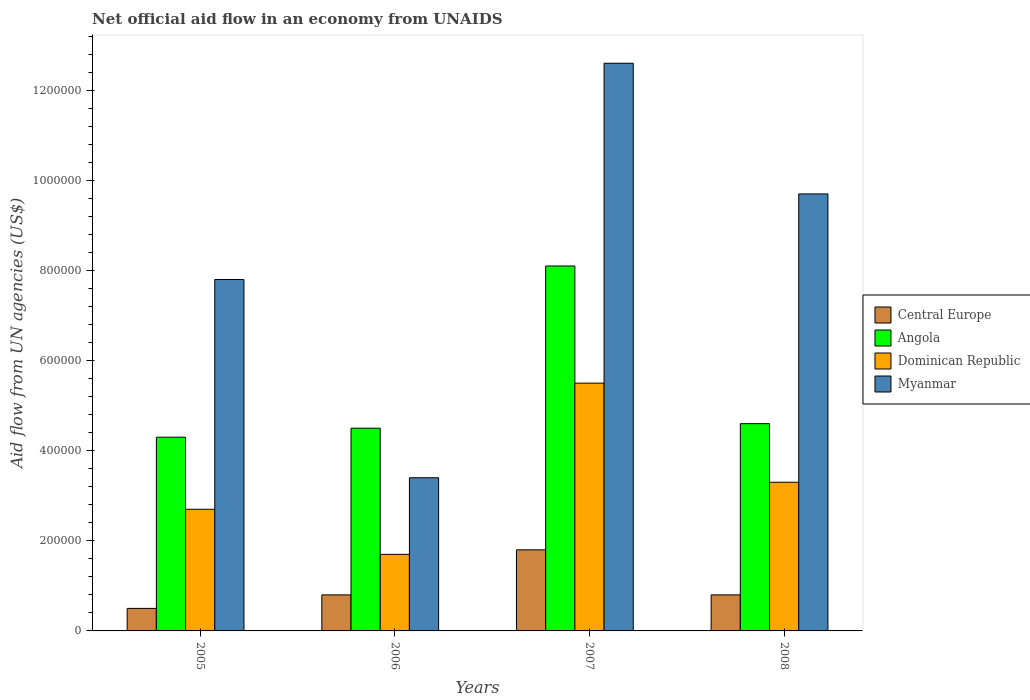How many different coloured bars are there?
Make the answer very short. 4. How many groups of bars are there?
Give a very brief answer. 4. Are the number of bars on each tick of the X-axis equal?
Your answer should be compact. Yes. How many bars are there on the 2nd tick from the left?
Keep it short and to the point. 4. How many bars are there on the 3rd tick from the right?
Make the answer very short. 4. What is the net official aid flow in Dominican Republic in 2006?
Your response must be concise. 1.70e+05. Across all years, what is the maximum net official aid flow in Myanmar?
Give a very brief answer. 1.26e+06. Across all years, what is the minimum net official aid flow in Myanmar?
Your response must be concise. 3.40e+05. In which year was the net official aid flow in Angola maximum?
Offer a terse response. 2007. What is the total net official aid flow in Dominican Republic in the graph?
Provide a succinct answer. 1.32e+06. What is the difference between the net official aid flow in Myanmar in 2005 and that in 2006?
Give a very brief answer. 4.40e+05. What is the average net official aid flow in Angola per year?
Provide a succinct answer. 5.38e+05. In the year 2007, what is the difference between the net official aid flow in Myanmar and net official aid flow in Angola?
Make the answer very short. 4.50e+05. In how many years, is the net official aid flow in Myanmar greater than 720000 US$?
Your answer should be very brief. 3. Is the net official aid flow in Angola in 2005 less than that in 2008?
Keep it short and to the point. Yes. What is the difference between the highest and the second highest net official aid flow in Myanmar?
Give a very brief answer. 2.90e+05. What is the difference between the highest and the lowest net official aid flow in Myanmar?
Offer a very short reply. 9.20e+05. In how many years, is the net official aid flow in Angola greater than the average net official aid flow in Angola taken over all years?
Your answer should be compact. 1. Is it the case that in every year, the sum of the net official aid flow in Myanmar and net official aid flow in Angola is greater than the sum of net official aid flow in Central Europe and net official aid flow in Dominican Republic?
Offer a terse response. No. What does the 2nd bar from the left in 2006 represents?
Your answer should be compact. Angola. What does the 2nd bar from the right in 2008 represents?
Your response must be concise. Dominican Republic. Is it the case that in every year, the sum of the net official aid flow in Dominican Republic and net official aid flow in Myanmar is greater than the net official aid flow in Central Europe?
Your answer should be very brief. Yes. Are all the bars in the graph horizontal?
Keep it short and to the point. No. How many years are there in the graph?
Give a very brief answer. 4. Are the values on the major ticks of Y-axis written in scientific E-notation?
Your answer should be compact. No. Does the graph contain grids?
Give a very brief answer. No. How many legend labels are there?
Provide a short and direct response. 4. How are the legend labels stacked?
Ensure brevity in your answer.  Vertical. What is the title of the graph?
Offer a terse response. Net official aid flow in an economy from UNAIDS. Does "Gabon" appear as one of the legend labels in the graph?
Provide a succinct answer. No. What is the label or title of the Y-axis?
Your response must be concise. Aid flow from UN agencies (US$). What is the Aid flow from UN agencies (US$) of Dominican Republic in 2005?
Offer a very short reply. 2.70e+05. What is the Aid flow from UN agencies (US$) in Myanmar in 2005?
Give a very brief answer. 7.80e+05. What is the Aid flow from UN agencies (US$) in Angola in 2006?
Provide a short and direct response. 4.50e+05. What is the Aid flow from UN agencies (US$) in Dominican Republic in 2006?
Provide a short and direct response. 1.70e+05. What is the Aid flow from UN agencies (US$) in Myanmar in 2006?
Your answer should be compact. 3.40e+05. What is the Aid flow from UN agencies (US$) of Central Europe in 2007?
Provide a short and direct response. 1.80e+05. What is the Aid flow from UN agencies (US$) in Angola in 2007?
Offer a very short reply. 8.10e+05. What is the Aid flow from UN agencies (US$) of Myanmar in 2007?
Keep it short and to the point. 1.26e+06. What is the Aid flow from UN agencies (US$) in Dominican Republic in 2008?
Offer a terse response. 3.30e+05. What is the Aid flow from UN agencies (US$) in Myanmar in 2008?
Provide a short and direct response. 9.70e+05. Across all years, what is the maximum Aid flow from UN agencies (US$) in Central Europe?
Provide a succinct answer. 1.80e+05. Across all years, what is the maximum Aid flow from UN agencies (US$) in Angola?
Keep it short and to the point. 8.10e+05. Across all years, what is the maximum Aid flow from UN agencies (US$) in Myanmar?
Ensure brevity in your answer.  1.26e+06. Across all years, what is the minimum Aid flow from UN agencies (US$) in Central Europe?
Ensure brevity in your answer.  5.00e+04. Across all years, what is the minimum Aid flow from UN agencies (US$) of Angola?
Give a very brief answer. 4.30e+05. Across all years, what is the minimum Aid flow from UN agencies (US$) in Dominican Republic?
Your answer should be very brief. 1.70e+05. Across all years, what is the minimum Aid flow from UN agencies (US$) in Myanmar?
Offer a terse response. 3.40e+05. What is the total Aid flow from UN agencies (US$) in Angola in the graph?
Keep it short and to the point. 2.15e+06. What is the total Aid flow from UN agencies (US$) of Dominican Republic in the graph?
Give a very brief answer. 1.32e+06. What is the total Aid flow from UN agencies (US$) in Myanmar in the graph?
Provide a succinct answer. 3.35e+06. What is the difference between the Aid flow from UN agencies (US$) in Angola in 2005 and that in 2006?
Your answer should be very brief. -2.00e+04. What is the difference between the Aid flow from UN agencies (US$) in Myanmar in 2005 and that in 2006?
Keep it short and to the point. 4.40e+05. What is the difference between the Aid flow from UN agencies (US$) in Angola in 2005 and that in 2007?
Your response must be concise. -3.80e+05. What is the difference between the Aid flow from UN agencies (US$) of Dominican Republic in 2005 and that in 2007?
Your answer should be compact. -2.80e+05. What is the difference between the Aid flow from UN agencies (US$) of Myanmar in 2005 and that in 2007?
Ensure brevity in your answer.  -4.80e+05. What is the difference between the Aid flow from UN agencies (US$) of Central Europe in 2005 and that in 2008?
Provide a succinct answer. -3.00e+04. What is the difference between the Aid flow from UN agencies (US$) of Dominican Republic in 2005 and that in 2008?
Make the answer very short. -6.00e+04. What is the difference between the Aid flow from UN agencies (US$) in Myanmar in 2005 and that in 2008?
Offer a terse response. -1.90e+05. What is the difference between the Aid flow from UN agencies (US$) in Central Europe in 2006 and that in 2007?
Keep it short and to the point. -1.00e+05. What is the difference between the Aid flow from UN agencies (US$) of Angola in 2006 and that in 2007?
Keep it short and to the point. -3.60e+05. What is the difference between the Aid flow from UN agencies (US$) of Dominican Republic in 2006 and that in 2007?
Your answer should be compact. -3.80e+05. What is the difference between the Aid flow from UN agencies (US$) in Myanmar in 2006 and that in 2007?
Give a very brief answer. -9.20e+05. What is the difference between the Aid flow from UN agencies (US$) of Central Europe in 2006 and that in 2008?
Your response must be concise. 0. What is the difference between the Aid flow from UN agencies (US$) of Myanmar in 2006 and that in 2008?
Your response must be concise. -6.30e+05. What is the difference between the Aid flow from UN agencies (US$) of Central Europe in 2007 and that in 2008?
Provide a short and direct response. 1.00e+05. What is the difference between the Aid flow from UN agencies (US$) in Angola in 2007 and that in 2008?
Give a very brief answer. 3.50e+05. What is the difference between the Aid flow from UN agencies (US$) of Central Europe in 2005 and the Aid flow from UN agencies (US$) of Angola in 2006?
Your response must be concise. -4.00e+05. What is the difference between the Aid flow from UN agencies (US$) in Central Europe in 2005 and the Aid flow from UN agencies (US$) in Dominican Republic in 2006?
Offer a terse response. -1.20e+05. What is the difference between the Aid flow from UN agencies (US$) in Angola in 2005 and the Aid flow from UN agencies (US$) in Dominican Republic in 2006?
Your response must be concise. 2.60e+05. What is the difference between the Aid flow from UN agencies (US$) of Angola in 2005 and the Aid flow from UN agencies (US$) of Myanmar in 2006?
Your response must be concise. 9.00e+04. What is the difference between the Aid flow from UN agencies (US$) in Central Europe in 2005 and the Aid flow from UN agencies (US$) in Angola in 2007?
Give a very brief answer. -7.60e+05. What is the difference between the Aid flow from UN agencies (US$) of Central Europe in 2005 and the Aid flow from UN agencies (US$) of Dominican Republic in 2007?
Make the answer very short. -5.00e+05. What is the difference between the Aid flow from UN agencies (US$) of Central Europe in 2005 and the Aid flow from UN agencies (US$) of Myanmar in 2007?
Your answer should be very brief. -1.21e+06. What is the difference between the Aid flow from UN agencies (US$) in Angola in 2005 and the Aid flow from UN agencies (US$) in Myanmar in 2007?
Keep it short and to the point. -8.30e+05. What is the difference between the Aid flow from UN agencies (US$) of Dominican Republic in 2005 and the Aid flow from UN agencies (US$) of Myanmar in 2007?
Provide a short and direct response. -9.90e+05. What is the difference between the Aid flow from UN agencies (US$) of Central Europe in 2005 and the Aid flow from UN agencies (US$) of Angola in 2008?
Provide a succinct answer. -4.10e+05. What is the difference between the Aid flow from UN agencies (US$) of Central Europe in 2005 and the Aid flow from UN agencies (US$) of Dominican Republic in 2008?
Your answer should be compact. -2.80e+05. What is the difference between the Aid flow from UN agencies (US$) in Central Europe in 2005 and the Aid flow from UN agencies (US$) in Myanmar in 2008?
Offer a very short reply. -9.20e+05. What is the difference between the Aid flow from UN agencies (US$) of Angola in 2005 and the Aid flow from UN agencies (US$) of Dominican Republic in 2008?
Offer a very short reply. 1.00e+05. What is the difference between the Aid flow from UN agencies (US$) of Angola in 2005 and the Aid flow from UN agencies (US$) of Myanmar in 2008?
Make the answer very short. -5.40e+05. What is the difference between the Aid flow from UN agencies (US$) in Dominican Republic in 2005 and the Aid flow from UN agencies (US$) in Myanmar in 2008?
Make the answer very short. -7.00e+05. What is the difference between the Aid flow from UN agencies (US$) of Central Europe in 2006 and the Aid flow from UN agencies (US$) of Angola in 2007?
Provide a short and direct response. -7.30e+05. What is the difference between the Aid flow from UN agencies (US$) of Central Europe in 2006 and the Aid flow from UN agencies (US$) of Dominican Republic in 2007?
Provide a short and direct response. -4.70e+05. What is the difference between the Aid flow from UN agencies (US$) of Central Europe in 2006 and the Aid flow from UN agencies (US$) of Myanmar in 2007?
Your response must be concise. -1.18e+06. What is the difference between the Aid flow from UN agencies (US$) in Angola in 2006 and the Aid flow from UN agencies (US$) in Dominican Republic in 2007?
Offer a very short reply. -1.00e+05. What is the difference between the Aid flow from UN agencies (US$) of Angola in 2006 and the Aid flow from UN agencies (US$) of Myanmar in 2007?
Keep it short and to the point. -8.10e+05. What is the difference between the Aid flow from UN agencies (US$) in Dominican Republic in 2006 and the Aid flow from UN agencies (US$) in Myanmar in 2007?
Ensure brevity in your answer.  -1.09e+06. What is the difference between the Aid flow from UN agencies (US$) in Central Europe in 2006 and the Aid flow from UN agencies (US$) in Angola in 2008?
Make the answer very short. -3.80e+05. What is the difference between the Aid flow from UN agencies (US$) of Central Europe in 2006 and the Aid flow from UN agencies (US$) of Myanmar in 2008?
Your answer should be compact. -8.90e+05. What is the difference between the Aid flow from UN agencies (US$) of Angola in 2006 and the Aid flow from UN agencies (US$) of Dominican Republic in 2008?
Provide a short and direct response. 1.20e+05. What is the difference between the Aid flow from UN agencies (US$) of Angola in 2006 and the Aid flow from UN agencies (US$) of Myanmar in 2008?
Your response must be concise. -5.20e+05. What is the difference between the Aid flow from UN agencies (US$) in Dominican Republic in 2006 and the Aid flow from UN agencies (US$) in Myanmar in 2008?
Your response must be concise. -8.00e+05. What is the difference between the Aid flow from UN agencies (US$) in Central Europe in 2007 and the Aid flow from UN agencies (US$) in Angola in 2008?
Provide a succinct answer. -2.80e+05. What is the difference between the Aid flow from UN agencies (US$) in Central Europe in 2007 and the Aid flow from UN agencies (US$) in Myanmar in 2008?
Offer a very short reply. -7.90e+05. What is the difference between the Aid flow from UN agencies (US$) in Angola in 2007 and the Aid flow from UN agencies (US$) in Dominican Republic in 2008?
Keep it short and to the point. 4.80e+05. What is the difference between the Aid flow from UN agencies (US$) of Angola in 2007 and the Aid flow from UN agencies (US$) of Myanmar in 2008?
Your answer should be compact. -1.60e+05. What is the difference between the Aid flow from UN agencies (US$) in Dominican Republic in 2007 and the Aid flow from UN agencies (US$) in Myanmar in 2008?
Give a very brief answer. -4.20e+05. What is the average Aid flow from UN agencies (US$) of Central Europe per year?
Your response must be concise. 9.75e+04. What is the average Aid flow from UN agencies (US$) of Angola per year?
Provide a short and direct response. 5.38e+05. What is the average Aid flow from UN agencies (US$) in Dominican Republic per year?
Provide a short and direct response. 3.30e+05. What is the average Aid flow from UN agencies (US$) in Myanmar per year?
Make the answer very short. 8.38e+05. In the year 2005, what is the difference between the Aid flow from UN agencies (US$) of Central Europe and Aid flow from UN agencies (US$) of Angola?
Your answer should be compact. -3.80e+05. In the year 2005, what is the difference between the Aid flow from UN agencies (US$) of Central Europe and Aid flow from UN agencies (US$) of Myanmar?
Keep it short and to the point. -7.30e+05. In the year 2005, what is the difference between the Aid flow from UN agencies (US$) in Angola and Aid flow from UN agencies (US$) in Dominican Republic?
Ensure brevity in your answer.  1.60e+05. In the year 2005, what is the difference between the Aid flow from UN agencies (US$) of Angola and Aid flow from UN agencies (US$) of Myanmar?
Keep it short and to the point. -3.50e+05. In the year 2005, what is the difference between the Aid flow from UN agencies (US$) of Dominican Republic and Aid flow from UN agencies (US$) of Myanmar?
Offer a terse response. -5.10e+05. In the year 2006, what is the difference between the Aid flow from UN agencies (US$) of Central Europe and Aid flow from UN agencies (US$) of Angola?
Offer a very short reply. -3.70e+05. In the year 2006, what is the difference between the Aid flow from UN agencies (US$) in Central Europe and Aid flow from UN agencies (US$) in Myanmar?
Keep it short and to the point. -2.60e+05. In the year 2006, what is the difference between the Aid flow from UN agencies (US$) of Angola and Aid flow from UN agencies (US$) of Myanmar?
Provide a succinct answer. 1.10e+05. In the year 2006, what is the difference between the Aid flow from UN agencies (US$) of Dominican Republic and Aid flow from UN agencies (US$) of Myanmar?
Offer a terse response. -1.70e+05. In the year 2007, what is the difference between the Aid flow from UN agencies (US$) in Central Europe and Aid flow from UN agencies (US$) in Angola?
Provide a succinct answer. -6.30e+05. In the year 2007, what is the difference between the Aid flow from UN agencies (US$) of Central Europe and Aid flow from UN agencies (US$) of Dominican Republic?
Make the answer very short. -3.70e+05. In the year 2007, what is the difference between the Aid flow from UN agencies (US$) of Central Europe and Aid flow from UN agencies (US$) of Myanmar?
Make the answer very short. -1.08e+06. In the year 2007, what is the difference between the Aid flow from UN agencies (US$) in Angola and Aid flow from UN agencies (US$) in Dominican Republic?
Your response must be concise. 2.60e+05. In the year 2007, what is the difference between the Aid flow from UN agencies (US$) of Angola and Aid flow from UN agencies (US$) of Myanmar?
Your response must be concise. -4.50e+05. In the year 2007, what is the difference between the Aid flow from UN agencies (US$) of Dominican Republic and Aid flow from UN agencies (US$) of Myanmar?
Your response must be concise. -7.10e+05. In the year 2008, what is the difference between the Aid flow from UN agencies (US$) in Central Europe and Aid flow from UN agencies (US$) in Angola?
Ensure brevity in your answer.  -3.80e+05. In the year 2008, what is the difference between the Aid flow from UN agencies (US$) in Central Europe and Aid flow from UN agencies (US$) in Myanmar?
Your answer should be compact. -8.90e+05. In the year 2008, what is the difference between the Aid flow from UN agencies (US$) of Angola and Aid flow from UN agencies (US$) of Myanmar?
Your answer should be compact. -5.10e+05. In the year 2008, what is the difference between the Aid flow from UN agencies (US$) of Dominican Republic and Aid flow from UN agencies (US$) of Myanmar?
Your answer should be very brief. -6.40e+05. What is the ratio of the Aid flow from UN agencies (US$) of Central Europe in 2005 to that in 2006?
Your answer should be compact. 0.62. What is the ratio of the Aid flow from UN agencies (US$) of Angola in 2005 to that in 2006?
Provide a succinct answer. 0.96. What is the ratio of the Aid flow from UN agencies (US$) in Dominican Republic in 2005 to that in 2006?
Your response must be concise. 1.59. What is the ratio of the Aid flow from UN agencies (US$) in Myanmar in 2005 to that in 2006?
Make the answer very short. 2.29. What is the ratio of the Aid flow from UN agencies (US$) in Central Europe in 2005 to that in 2007?
Offer a terse response. 0.28. What is the ratio of the Aid flow from UN agencies (US$) in Angola in 2005 to that in 2007?
Offer a terse response. 0.53. What is the ratio of the Aid flow from UN agencies (US$) of Dominican Republic in 2005 to that in 2007?
Provide a short and direct response. 0.49. What is the ratio of the Aid flow from UN agencies (US$) in Myanmar in 2005 to that in 2007?
Provide a short and direct response. 0.62. What is the ratio of the Aid flow from UN agencies (US$) in Angola in 2005 to that in 2008?
Ensure brevity in your answer.  0.93. What is the ratio of the Aid flow from UN agencies (US$) of Dominican Republic in 2005 to that in 2008?
Offer a very short reply. 0.82. What is the ratio of the Aid flow from UN agencies (US$) in Myanmar in 2005 to that in 2008?
Your answer should be compact. 0.8. What is the ratio of the Aid flow from UN agencies (US$) in Central Europe in 2006 to that in 2007?
Provide a short and direct response. 0.44. What is the ratio of the Aid flow from UN agencies (US$) of Angola in 2006 to that in 2007?
Ensure brevity in your answer.  0.56. What is the ratio of the Aid flow from UN agencies (US$) in Dominican Republic in 2006 to that in 2007?
Your response must be concise. 0.31. What is the ratio of the Aid flow from UN agencies (US$) in Myanmar in 2006 to that in 2007?
Make the answer very short. 0.27. What is the ratio of the Aid flow from UN agencies (US$) in Central Europe in 2006 to that in 2008?
Your answer should be very brief. 1. What is the ratio of the Aid flow from UN agencies (US$) of Angola in 2006 to that in 2008?
Give a very brief answer. 0.98. What is the ratio of the Aid flow from UN agencies (US$) of Dominican Republic in 2006 to that in 2008?
Your answer should be very brief. 0.52. What is the ratio of the Aid flow from UN agencies (US$) in Myanmar in 2006 to that in 2008?
Keep it short and to the point. 0.35. What is the ratio of the Aid flow from UN agencies (US$) in Central Europe in 2007 to that in 2008?
Offer a terse response. 2.25. What is the ratio of the Aid flow from UN agencies (US$) in Angola in 2007 to that in 2008?
Your answer should be very brief. 1.76. What is the ratio of the Aid flow from UN agencies (US$) in Dominican Republic in 2007 to that in 2008?
Provide a short and direct response. 1.67. What is the ratio of the Aid flow from UN agencies (US$) of Myanmar in 2007 to that in 2008?
Your answer should be very brief. 1.3. What is the difference between the highest and the second highest Aid flow from UN agencies (US$) of Central Europe?
Keep it short and to the point. 1.00e+05. What is the difference between the highest and the second highest Aid flow from UN agencies (US$) in Dominican Republic?
Ensure brevity in your answer.  2.20e+05. What is the difference between the highest and the second highest Aid flow from UN agencies (US$) of Myanmar?
Offer a very short reply. 2.90e+05. What is the difference between the highest and the lowest Aid flow from UN agencies (US$) in Central Europe?
Ensure brevity in your answer.  1.30e+05. What is the difference between the highest and the lowest Aid flow from UN agencies (US$) in Angola?
Your answer should be compact. 3.80e+05. What is the difference between the highest and the lowest Aid flow from UN agencies (US$) of Myanmar?
Ensure brevity in your answer.  9.20e+05. 